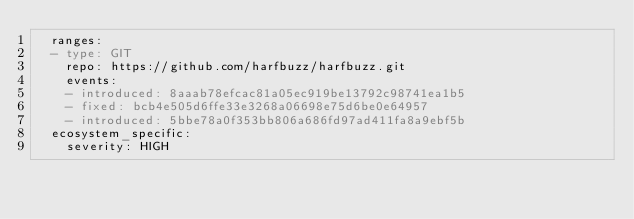<code> <loc_0><loc_0><loc_500><loc_500><_YAML_>  ranges:
  - type: GIT
    repo: https://github.com/harfbuzz/harfbuzz.git
    events:
    - introduced: 8aaab78efcac81a05ec919be13792c98741ea1b5
    - fixed: bcb4e505d6ffe33e3268a06698e75d6be0e64957
    - introduced: 5bbe78a0f353bb806a686fd97ad411fa8a9ebf5b
  ecosystem_specific:
    severity: HIGH
</code> 